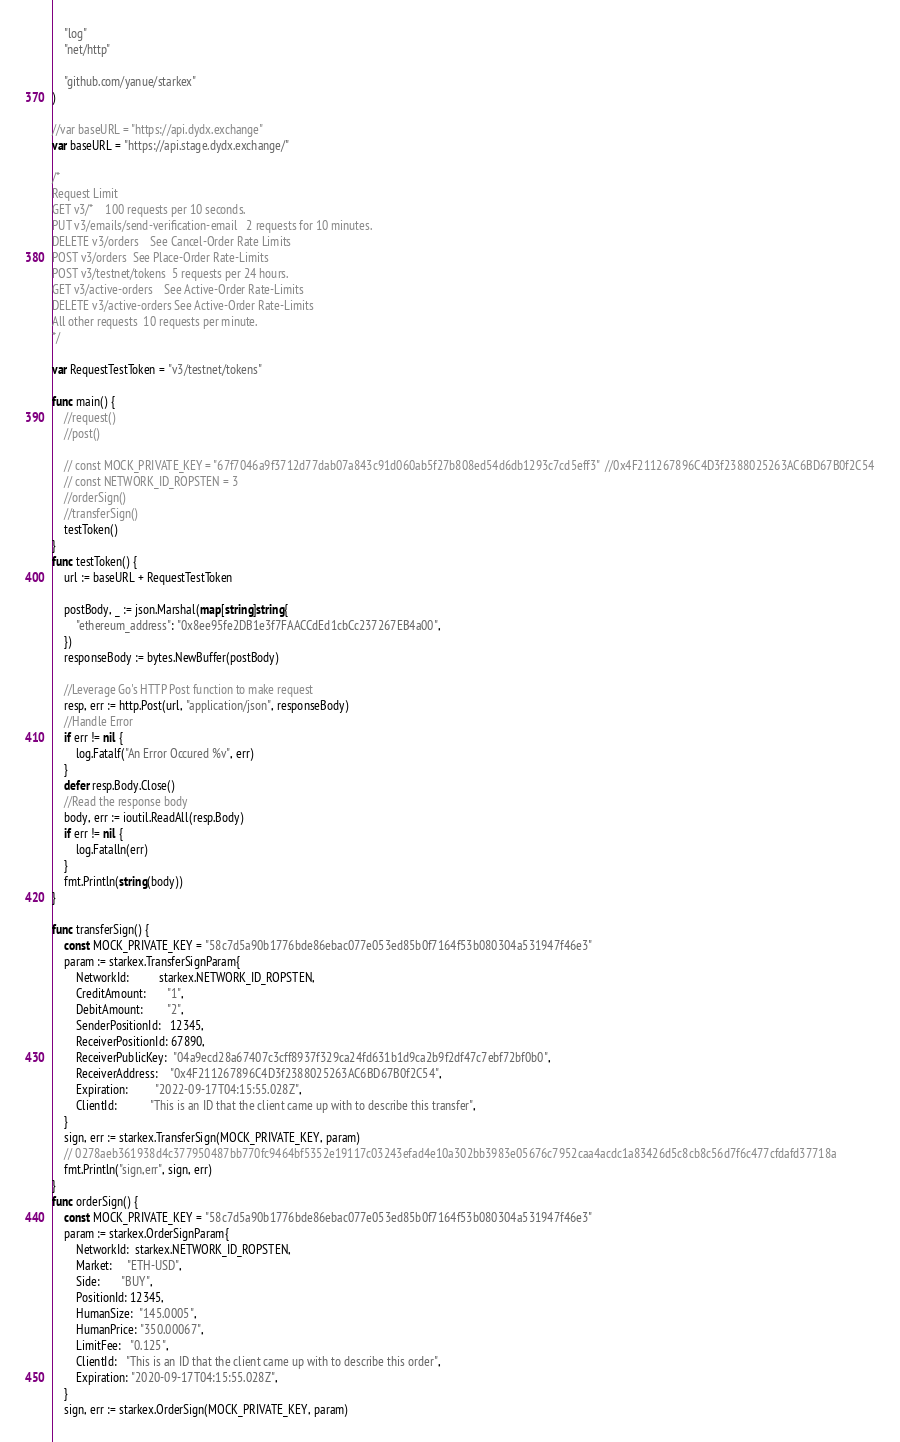Convert code to text. <code><loc_0><loc_0><loc_500><loc_500><_Go_>	"log"
	"net/http"

	"github.com/yanue/starkex"
)

//var baseURL = "https://api.dydx.exchange"
var baseURL = "https://api.stage.dydx.exchange/"

/*
Request	Limit
GET v3/*	100 requests per 10 seconds.
PUT v3/emails/send-verification-email	2 requests for 10 minutes.
DELETE v3/orders	See Cancel-Order Rate Limits
POST v3/orders	See Place-Order Rate-Limits
POST v3/testnet/tokens	5 requests per 24 hours.
GET v3/active-orders	See Active-Order Rate-Limits
DELETE v3/active-orders	See Active-Order Rate-Limits
All other requests	10 requests per minute.
*/

var RequestTestToken = "v3/testnet/tokens"

func main() {
	//request()
	//post()

	// const MOCK_PRIVATE_KEY = "67f7046a9f3712d77dab07a843c91d060ab5f27b808ed54d6db1293c7cd5eff3"  //0x4F211267896C4D3f2388025263AC6BD67B0f2C54
	// const NETWORK_ID_ROPSTEN = 3
	//orderSign()
	//transferSign()
	testToken()
}
func testToken() {
	url := baseURL + RequestTestToken

	postBody, _ := json.Marshal(map[string]string{
		"ethereum_address": "0x8ee95fe2DB1e3f7FAACCdEd1cbCc237267EB4a00",
	})
	responseBody := bytes.NewBuffer(postBody)

	//Leverage Go's HTTP Post function to make request
	resp, err := http.Post(url, "application/json", responseBody)
	//Handle Error
	if err != nil {
		log.Fatalf("An Error Occured %v", err)
	}
	defer resp.Body.Close()
	//Read the response body
	body, err := ioutil.ReadAll(resp.Body)
	if err != nil {
		log.Fatalln(err)
	}
	fmt.Println(string(body))
}

func transferSign() {
	const MOCK_PRIVATE_KEY = "58c7d5a90b1776bde86ebac077e053ed85b0f7164f53b080304a531947f46e3"
	param := starkex.TransferSignParam{
		NetworkId:          starkex.NETWORK_ID_ROPSTEN,
		CreditAmount:       "1",
		DebitAmount:        "2",
		SenderPositionId:   12345,
		ReceiverPositionId: 67890,
		ReceiverPublicKey:  "04a9ecd28a67407c3cff8937f329ca24fd631b1d9ca2b9f2df47c7ebf72bf0b0",
		ReceiverAddress:    "0x4F211267896C4D3f2388025263AC6BD67B0f2C54",
		Expiration:         "2022-09-17T04:15:55.028Z",
		ClientId:           "This is an ID that the client came up with to describe this transfer",
	}
	sign, err := starkex.TransferSign(MOCK_PRIVATE_KEY, param)
	// 0278aeb361938d4c377950487bb770fc9464bf5352e19117c03243efad4e10a302bb3983e05676c7952caa4acdc1a83426d5c8cb8c56d7f6c477cfdafd37718a
	fmt.Println("sign,err", sign, err)
}
func orderSign() {
	const MOCK_PRIVATE_KEY = "58c7d5a90b1776bde86ebac077e053ed85b0f7164f53b080304a531947f46e3"
	param := starkex.OrderSignParam{
		NetworkId:  starkex.NETWORK_ID_ROPSTEN,
		Market:     "ETH-USD",
		Side:       "BUY",
		PositionId: 12345,
		HumanSize:  "145.0005",
		HumanPrice: "350.00067",
		LimitFee:   "0.125",
		ClientId:   "This is an ID that the client came up with to describe this order",
		Expiration: "2020-09-17T04:15:55.028Z",
	}
	sign, err := starkex.OrderSign(MOCK_PRIVATE_KEY, param)</code> 